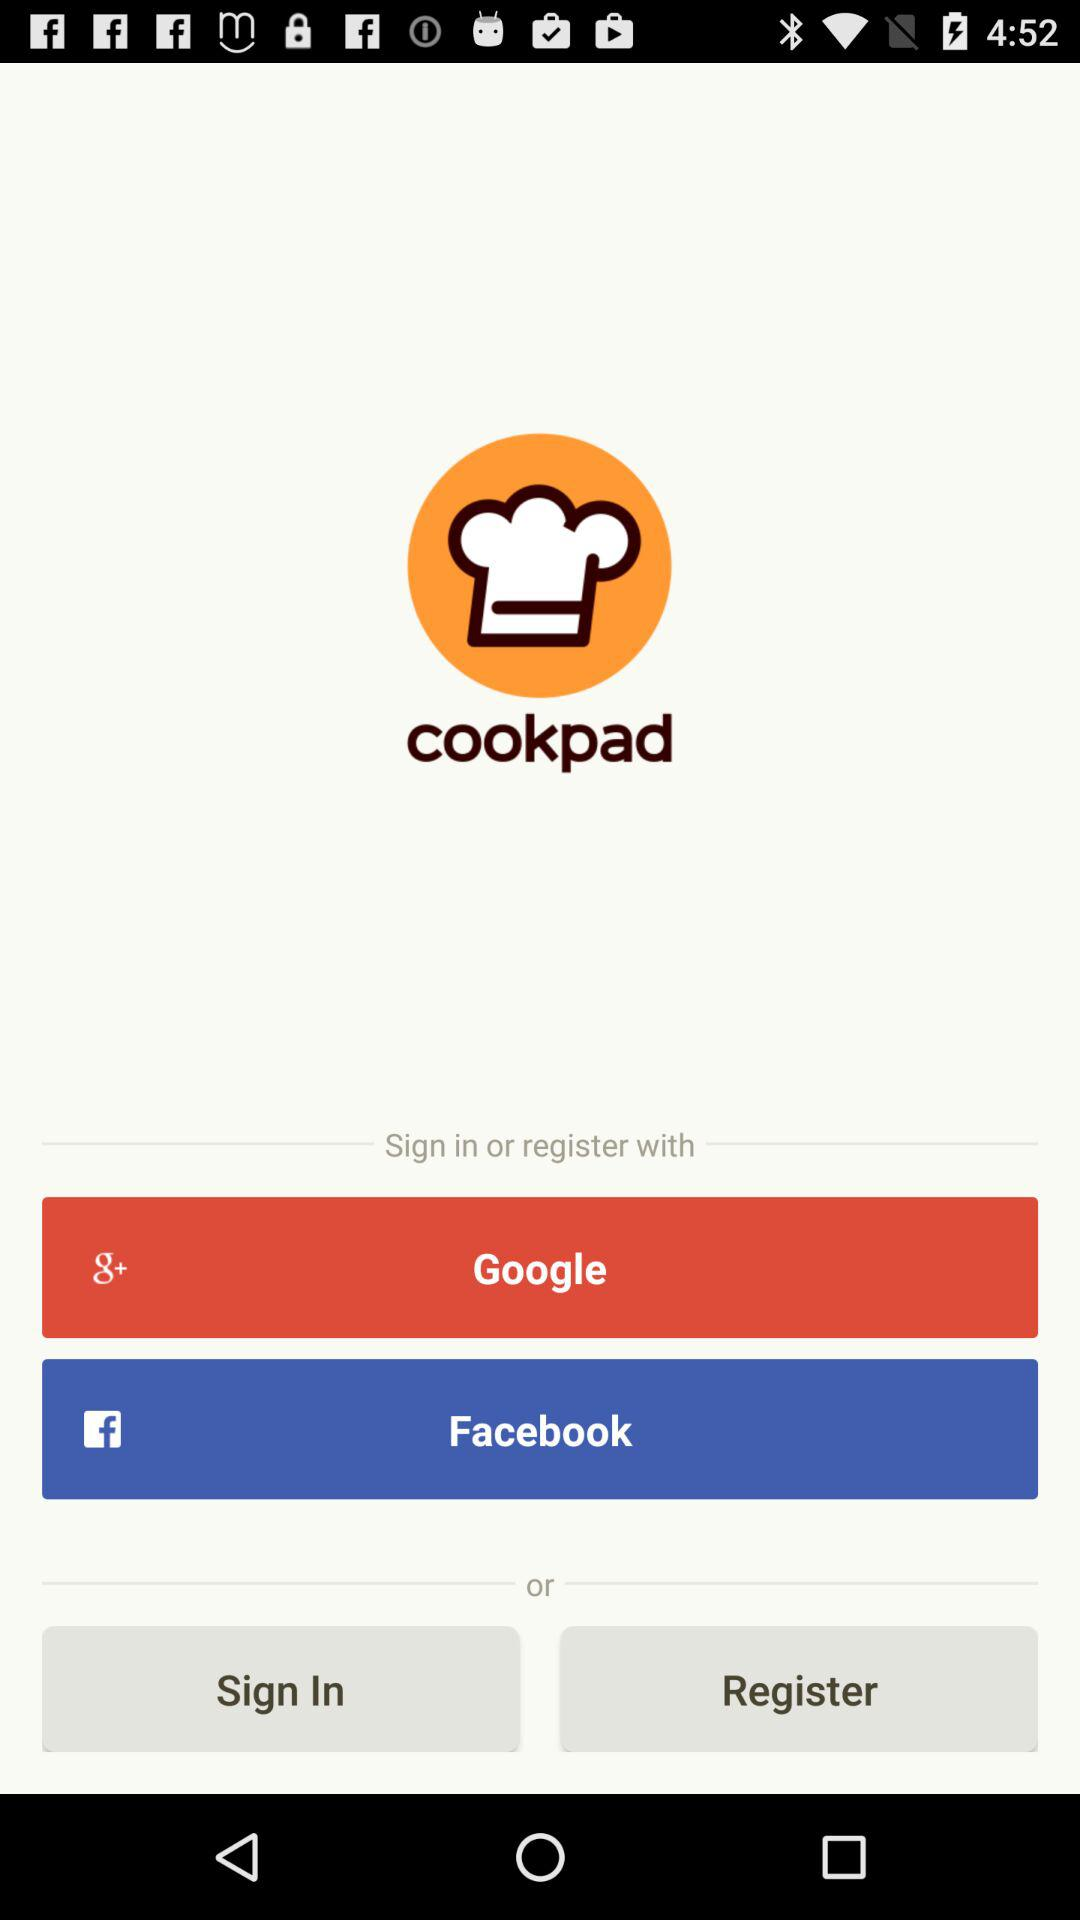What is the name of the application? The name of the application is "cookpad". 